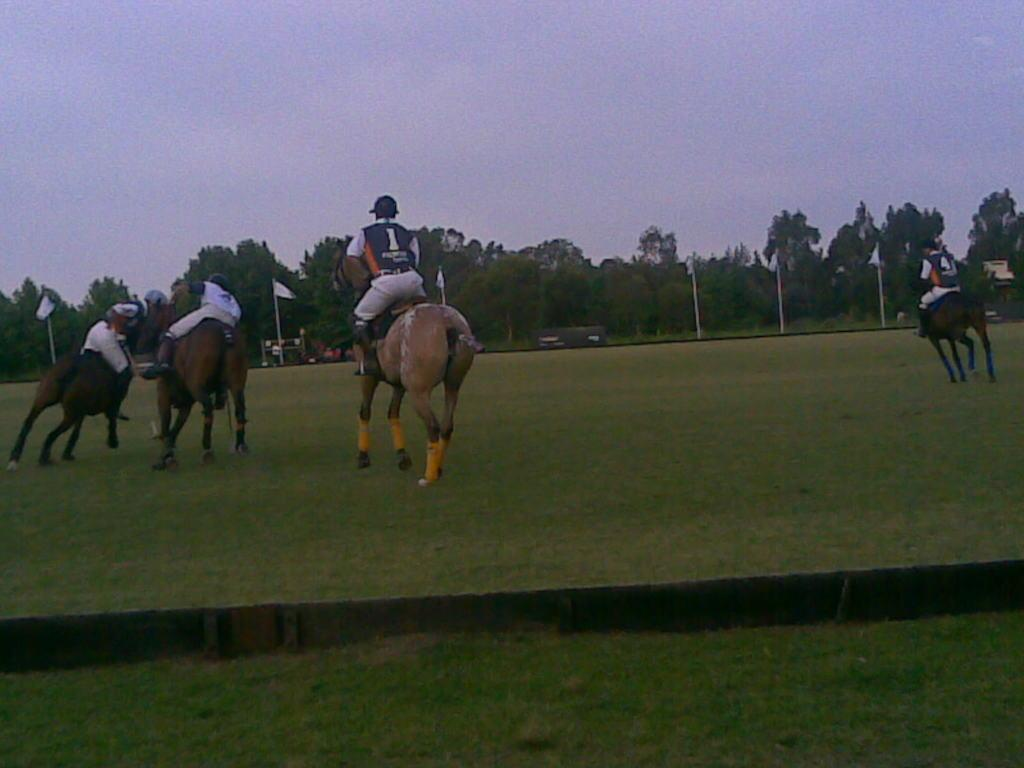What are the people in the image doing? The people in the image are riding horses. What is the terrain where the horses are located? The horses are on the grass. What is in front of the people while they are riding the horses? There is a board and poles with flags in front of the people. What type of vegetation is visible in the image? There are trees in front of the people. What can be seen in the sky in the image? The sky is visible in the image. What type of boot is being used to lead the horses in the image? There is no boot or leading of horses depicted in the image; the people are simply riding the horses. 